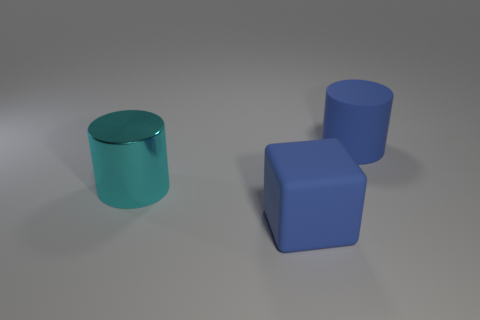What number of other things are the same shape as the cyan thing?
Provide a succinct answer. 1. There is a blue rubber thing that is in front of the large blue rubber cylinder; are there any large cylinders in front of it?
Your answer should be compact. No. What number of big matte things are there?
Offer a terse response. 2. Do the matte cylinder and the big thing on the left side of the big blue block have the same color?
Provide a short and direct response. No. Are there more small green balls than big metallic objects?
Provide a succinct answer. No. Are there any other things that are the same color as the shiny cylinder?
Offer a terse response. No. How many other things are there of the same size as the blue matte cylinder?
Provide a short and direct response. 2. The blue object that is behind the cylinder in front of the large blue rubber cylinder that is behind the blue matte cube is made of what material?
Your answer should be very brief. Rubber. Does the cyan cylinder have the same material as the blue object that is behind the large blue matte cube?
Keep it short and to the point. No. Are there fewer metal cylinders behind the large blue block than metal things that are on the right side of the cyan cylinder?
Keep it short and to the point. No. 